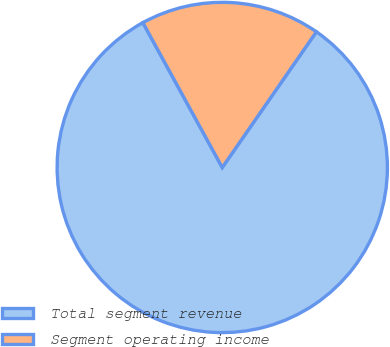Convert chart to OTSL. <chart><loc_0><loc_0><loc_500><loc_500><pie_chart><fcel>Total segment revenue<fcel>Segment operating income<nl><fcel>82.37%<fcel>17.63%<nl></chart> 